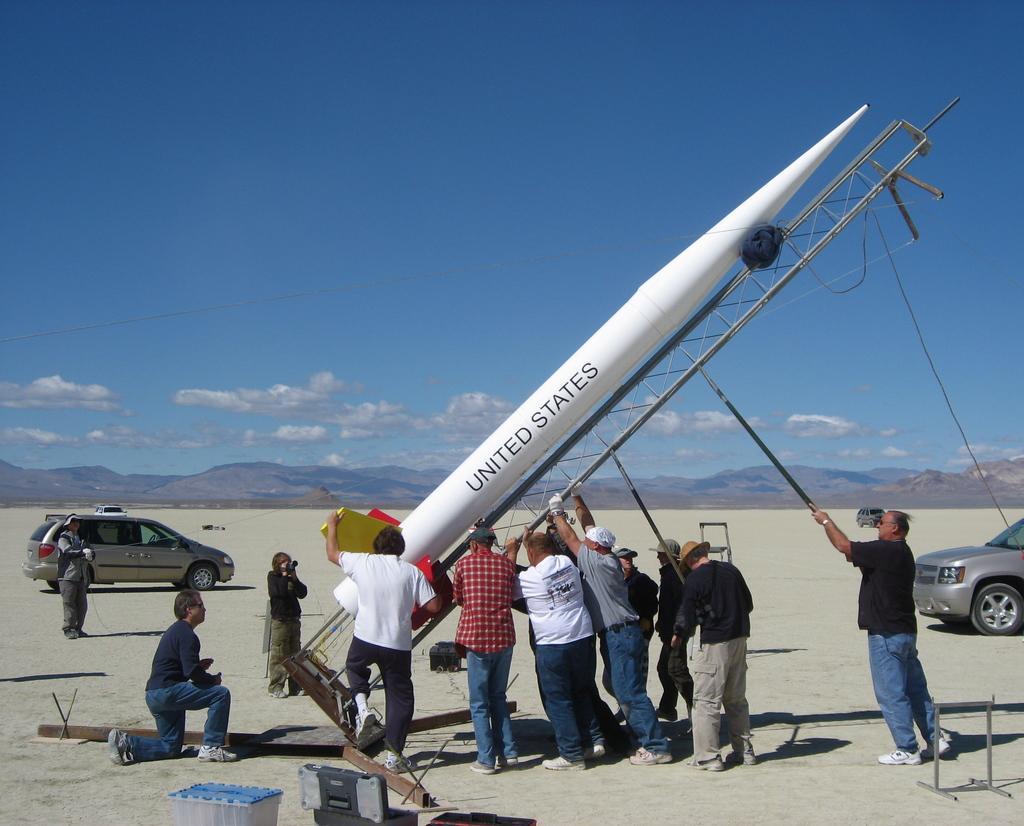Describe this image in one or two sentences. In this image we can see few people on the ground, some of them are holding a metal object and a person is holding rocket, a person is holding a camera, there are boxes, few metal rods and vehicles and in the background there are mountains and the sky with clouds 